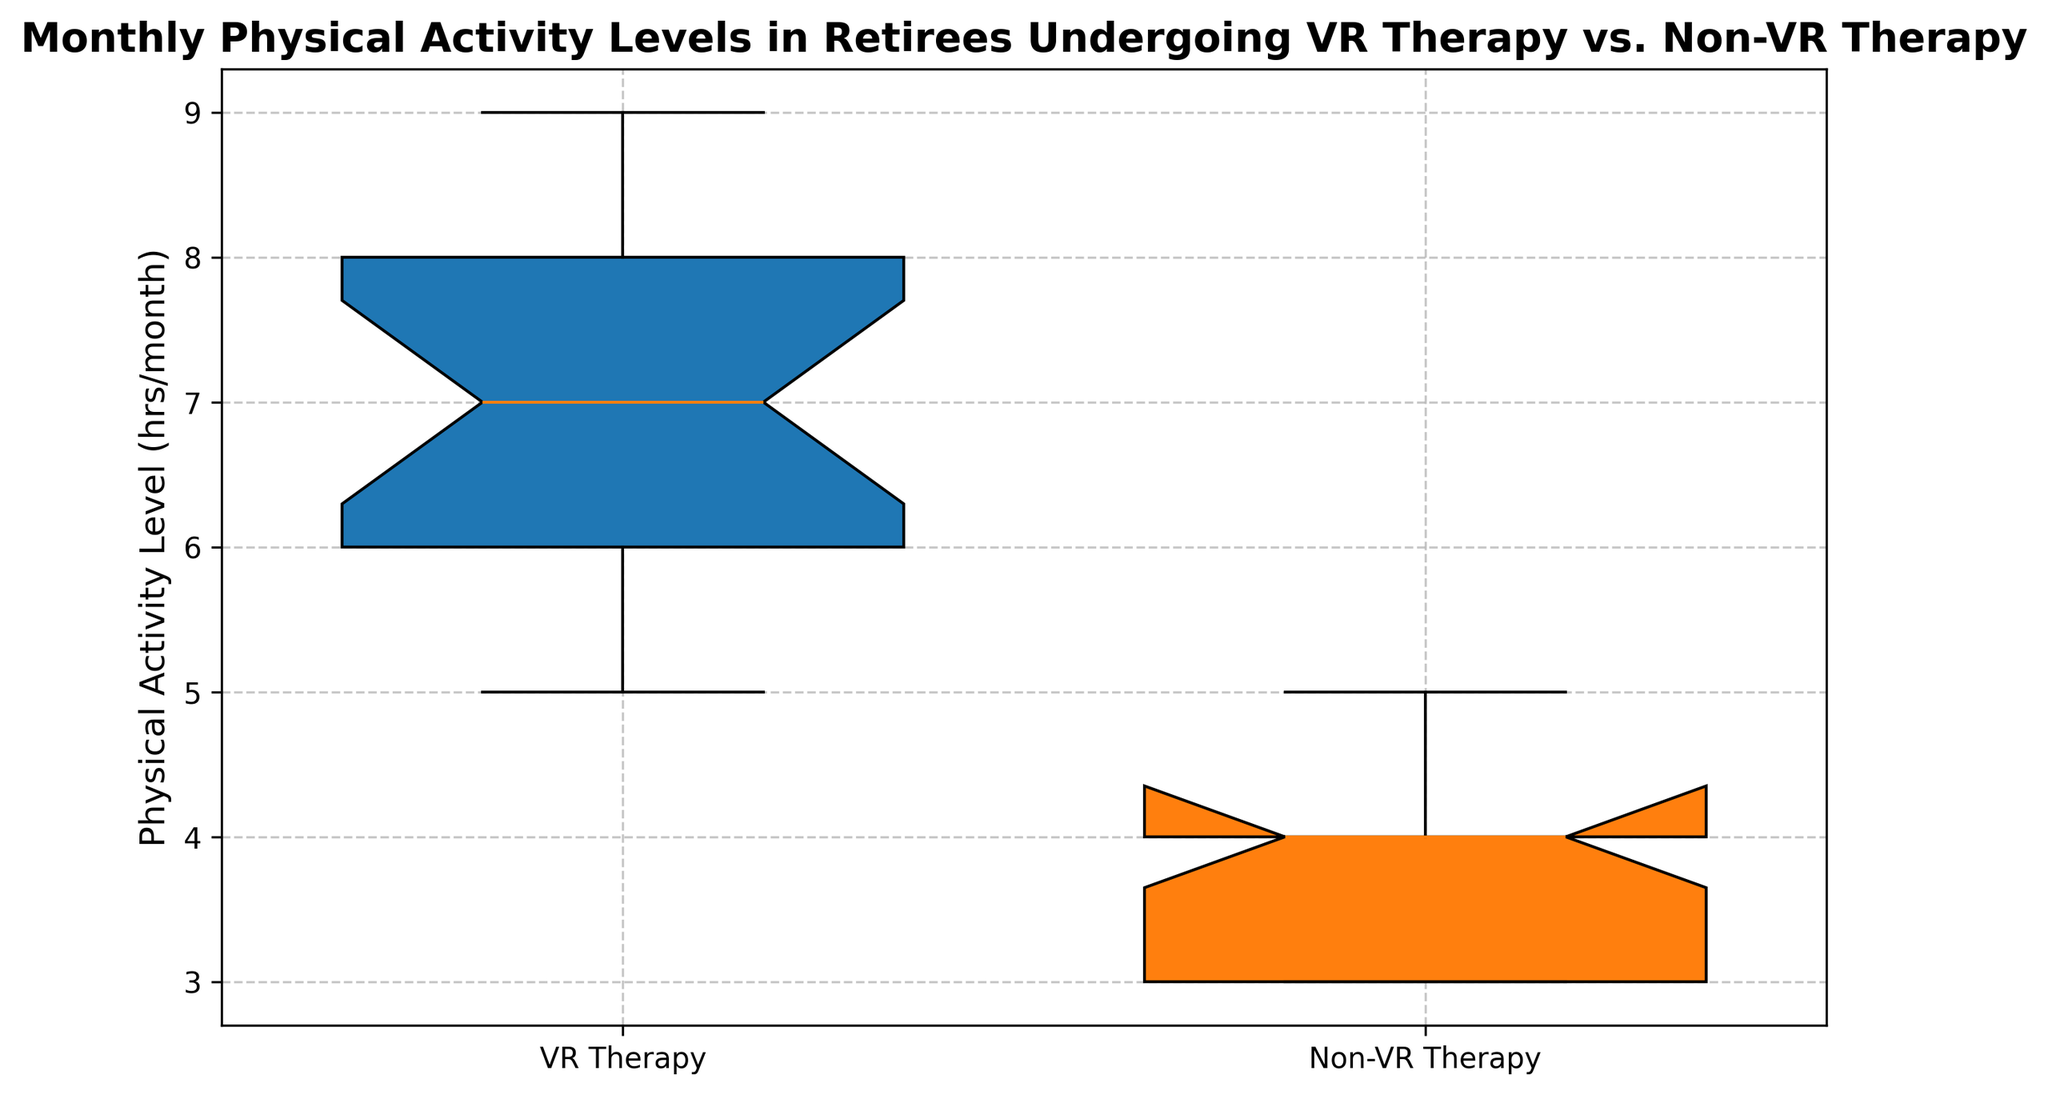Which group shows a higher median physical activity level? To find the median in a box plot, look for the line inside the box representing the median value. The box representing VR Therapy has a median line at a higher physical activity level compared to the Non-VR Therapy box.
Answer: VR Therapy What is the approximate median physical activity level for the VR Therapy group? The median is the line inside the box. In the box for VR Therapy, this line is at approximately 7 hours/month.
Answer: 7 hours/month Which group has a larger interquartile range (IQR)? The IQR is the range within the box (from the lower quartile to the upper quartile). Visually, both boxes have very similar IQRs, but VR Therapy's IQR seems slightly larger.
Answer: VR Therapy Which group has more variability in their physical activity levels? Variability can be gauged by looking at the spread of the whiskers and the box. The box and whiskers for VR Therapy cover a slightly larger range than those for Non-VR Therapy, indicating more variability.
Answer: VR Therapy Which group has the highest physical activity level recorded, and what is that level? Look at the highest point of the whiskers. For VR Therapy, the top whisker extends to 9 hours/month, which is higher than Non-VR Therapy's maximum.
Answer: VR Therapy, 9 hours/month What's the difference between the median physical activity levels of the two groups? Subtract the median physical activity level of Non-VR Therapy (around 4 hrs/month) from the median for VR Therapy (7 hrs/month): 7 - 4 = 3 hours/month.
Answer: 3 hours/month Which group appears to have an outlier, if any, and where is it located? Outliers are typically displayed as individual points outside the whiskers. Neither group shows any such points, indicating there are no outliers.
Answer: Neither How does the lowest recorded physical activity level compare between the groups? The lowest value is the bottom line of the whiskers. For VR Therapy, it's 5 hours/month, while for Non-VR Therapy, it's 3 hours/month.
Answer: Non-VR Therapy is lower If you were to recommend a group for improving physical activity, which one would it be and why? The recommendation should be based on higher central tendency and variability. VR Therapy has a higher median and greater variability, indicating it might better improve physical activity levels.
Answer: VR Therapy 